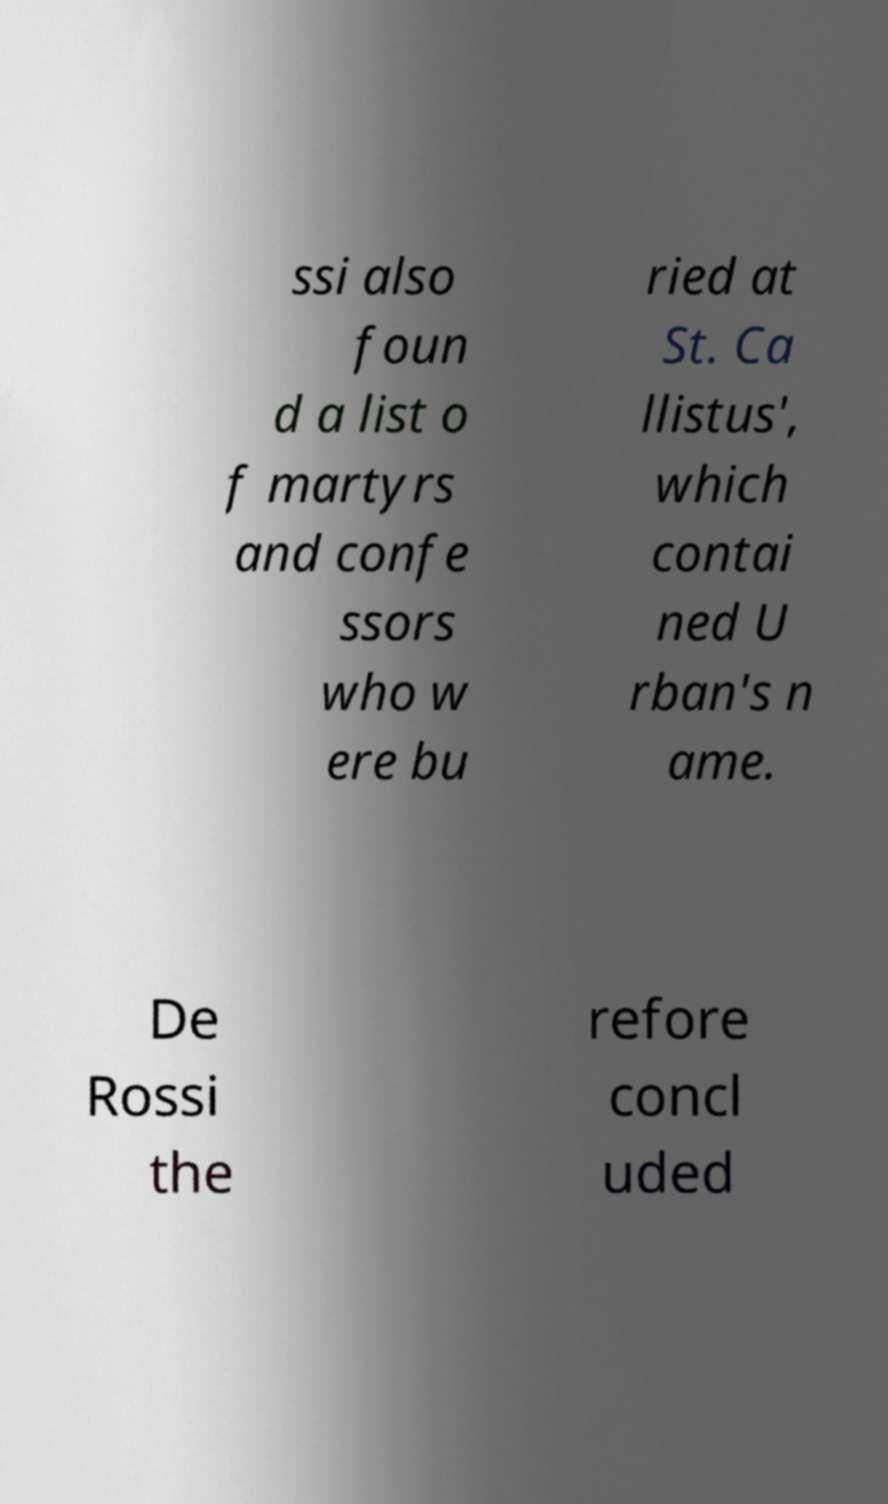What messages or text are displayed in this image? I need them in a readable, typed format. ssi also foun d a list o f martyrs and confe ssors who w ere bu ried at St. Ca llistus', which contai ned U rban's n ame. De Rossi the refore concl uded 